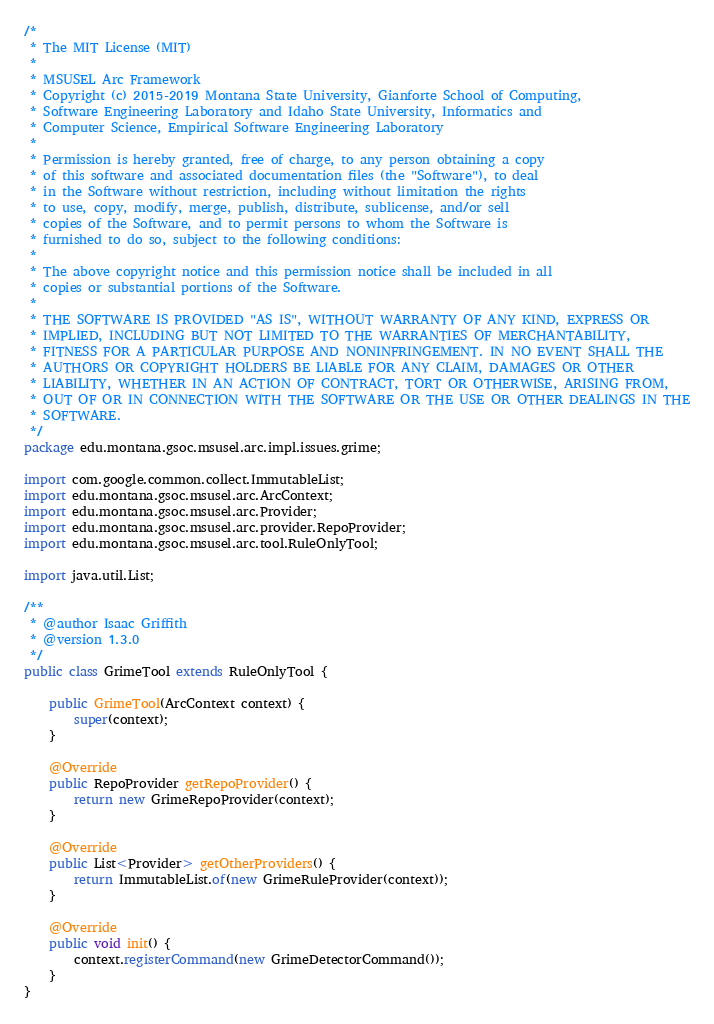<code> <loc_0><loc_0><loc_500><loc_500><_Java_>/*
 * The MIT License (MIT)
 *
 * MSUSEL Arc Framework
 * Copyright (c) 2015-2019 Montana State University, Gianforte School of Computing,
 * Software Engineering Laboratory and Idaho State University, Informatics and
 * Computer Science, Empirical Software Engineering Laboratory
 *
 * Permission is hereby granted, free of charge, to any person obtaining a copy
 * of this software and associated documentation files (the "Software"), to deal
 * in the Software without restriction, including without limitation the rights
 * to use, copy, modify, merge, publish, distribute, sublicense, and/or sell
 * copies of the Software, and to permit persons to whom the Software is
 * furnished to do so, subject to the following conditions:
 *
 * The above copyright notice and this permission notice shall be included in all
 * copies or substantial portions of the Software.
 *
 * THE SOFTWARE IS PROVIDED "AS IS", WITHOUT WARRANTY OF ANY KIND, EXPRESS OR
 * IMPLIED, INCLUDING BUT NOT LIMITED TO THE WARRANTIES OF MERCHANTABILITY,
 * FITNESS FOR A PARTICULAR PURPOSE AND NONINFRINGEMENT. IN NO EVENT SHALL THE
 * AUTHORS OR COPYRIGHT HOLDERS BE LIABLE FOR ANY CLAIM, DAMAGES OR OTHER
 * LIABILITY, WHETHER IN AN ACTION OF CONTRACT, TORT OR OTHERWISE, ARISING FROM,
 * OUT OF OR IN CONNECTION WITH THE SOFTWARE OR THE USE OR OTHER DEALINGS IN THE
 * SOFTWARE.
 */
package edu.montana.gsoc.msusel.arc.impl.issues.grime;

import com.google.common.collect.ImmutableList;
import edu.montana.gsoc.msusel.arc.ArcContext;
import edu.montana.gsoc.msusel.arc.Provider;
import edu.montana.gsoc.msusel.arc.provider.RepoProvider;
import edu.montana.gsoc.msusel.arc.tool.RuleOnlyTool;

import java.util.List;

/**
 * @author Isaac Griffith
 * @version 1.3.0
 */
public class GrimeTool extends RuleOnlyTool {

    public GrimeTool(ArcContext context) {
        super(context);
    }

    @Override
    public RepoProvider getRepoProvider() {
        return new GrimeRepoProvider(context);
    }

    @Override
    public List<Provider> getOtherProviders() {
        return ImmutableList.of(new GrimeRuleProvider(context));
    }

    @Override
    public void init() {
        context.registerCommand(new GrimeDetectorCommand());
    }
}
</code> 